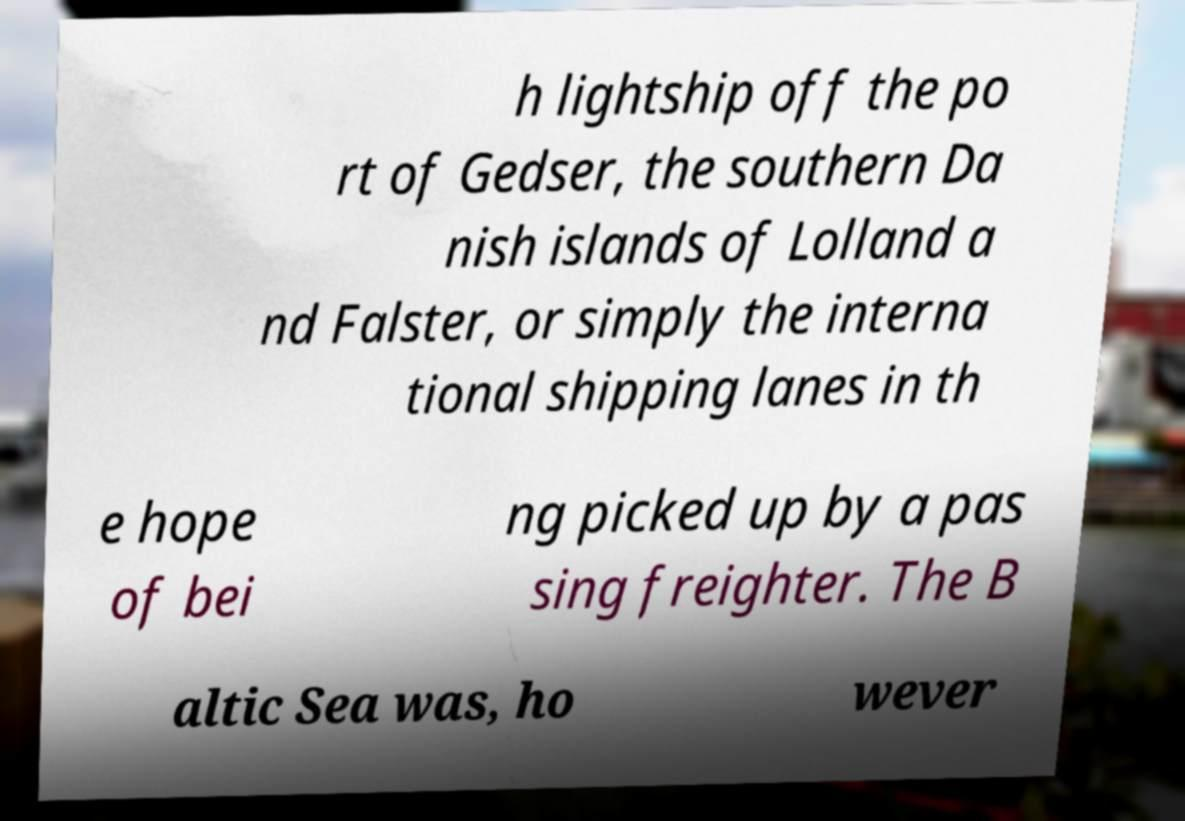Please identify and transcribe the text found in this image. h lightship off the po rt of Gedser, the southern Da nish islands of Lolland a nd Falster, or simply the interna tional shipping lanes in th e hope of bei ng picked up by a pas sing freighter. The B altic Sea was, ho wever 